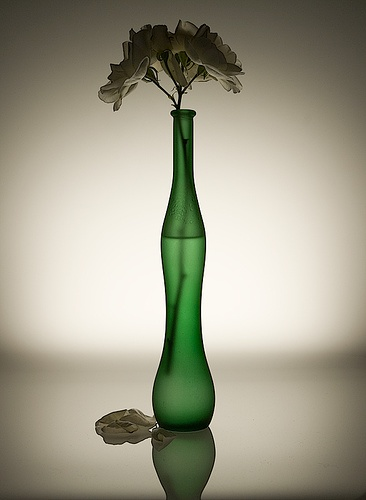Describe the objects in this image and their specific colors. I can see a vase in black, darkgreen, green, and ivory tones in this image. 